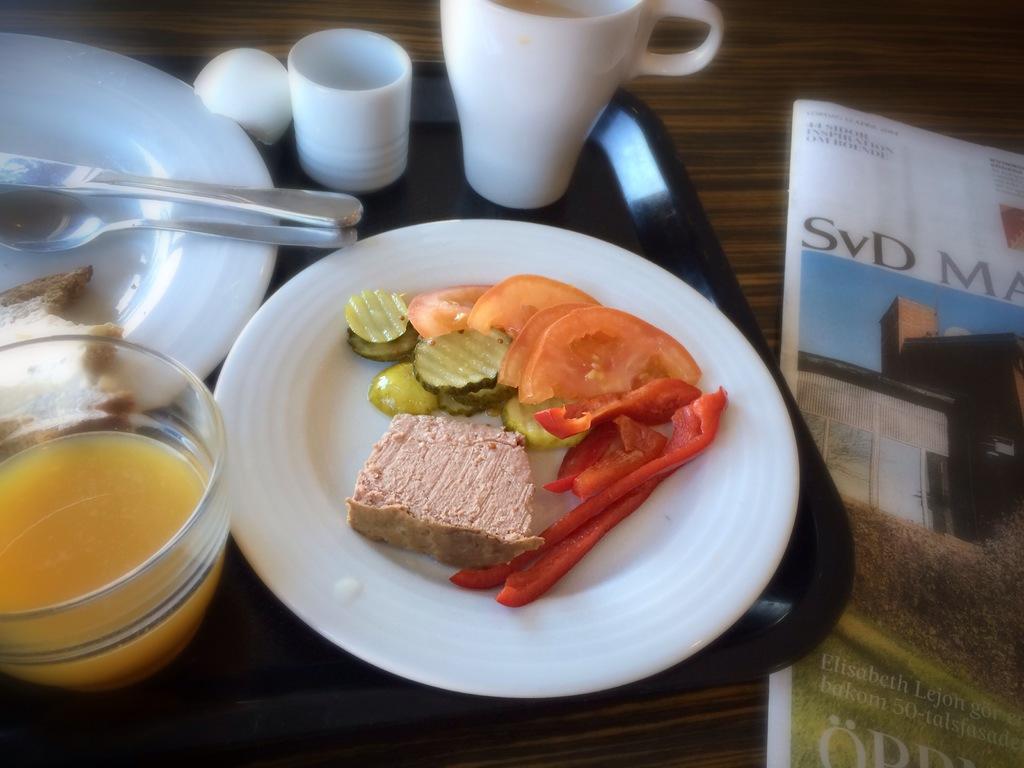Describe this image in one or two sentences. In the foreground of this picture, there is a platter with food, bowls, mug, and another platter with spoon and knife on it is placed on a black tray. On the right, there is a new paper on a wooden surface. 